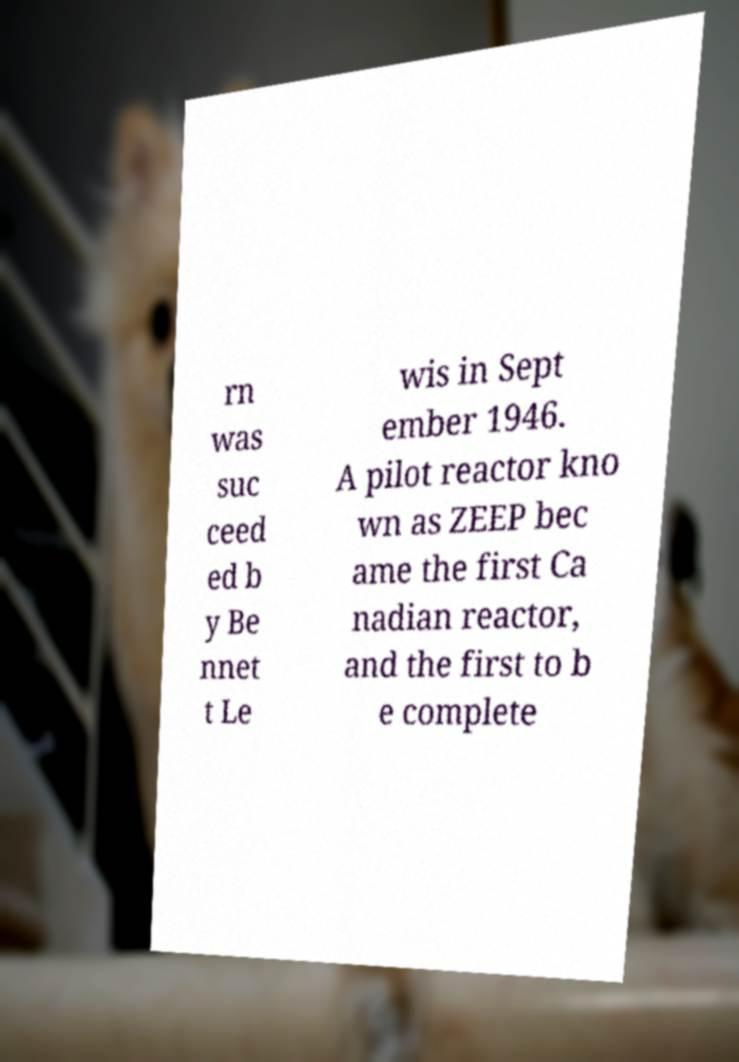There's text embedded in this image that I need extracted. Can you transcribe it verbatim? rn was suc ceed ed b y Be nnet t Le wis in Sept ember 1946. A pilot reactor kno wn as ZEEP bec ame the first Ca nadian reactor, and the first to b e complete 